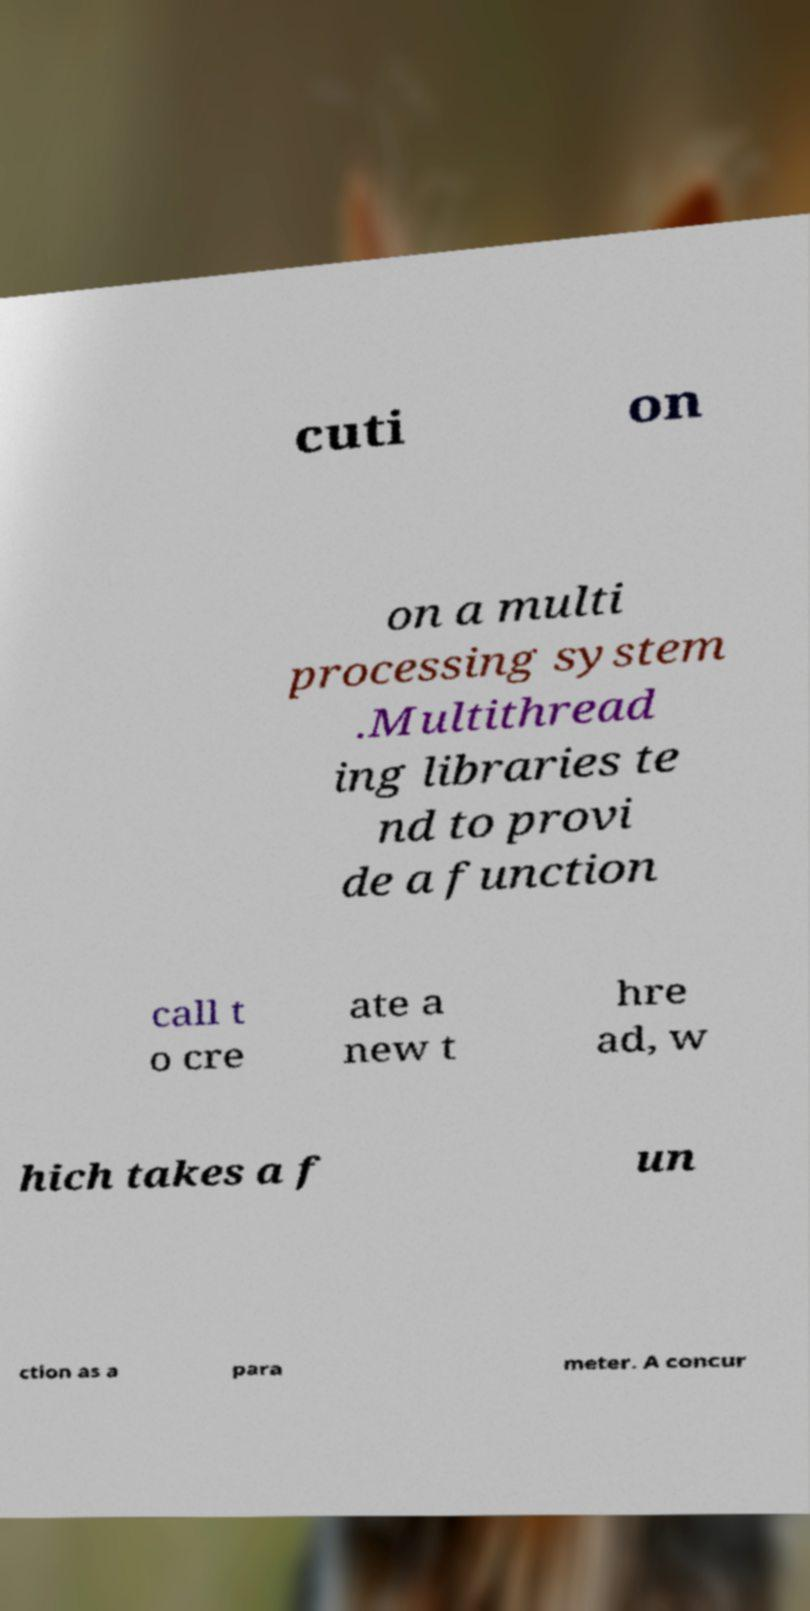For documentation purposes, I need the text within this image transcribed. Could you provide that? cuti on on a multi processing system .Multithread ing libraries te nd to provi de a function call t o cre ate a new t hre ad, w hich takes a f un ction as a para meter. A concur 